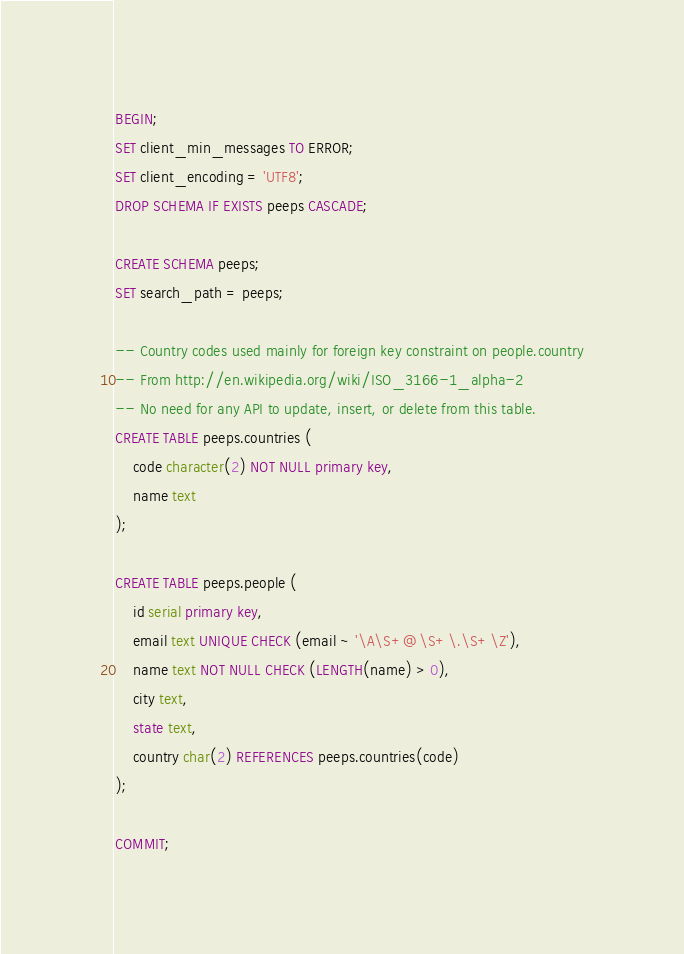Convert code to text. <code><loc_0><loc_0><loc_500><loc_500><_SQL_>BEGIN;
SET client_min_messages TO ERROR;
SET client_encoding = 'UTF8';
DROP SCHEMA IF EXISTS peeps CASCADE;

CREATE SCHEMA peeps;
SET search_path = peeps;

-- Country codes used mainly for foreign key constraint on people.country
-- From http://en.wikipedia.org/wiki/ISO_3166-1_alpha-2 
-- No need for any API to update, insert, or delete from this table.
CREATE TABLE peeps.countries (
	code character(2) NOT NULL primary key,
	name text
);

CREATE TABLE peeps.people (
	id serial primary key,
	email text UNIQUE CHECK (email ~ '\A\S+@\S+\.\S+\Z'),
	name text NOT NULL CHECK (LENGTH(name) > 0),
	city text,
	state text,
	country char(2) REFERENCES peeps.countries(code)
);

COMMIT;
</code> 